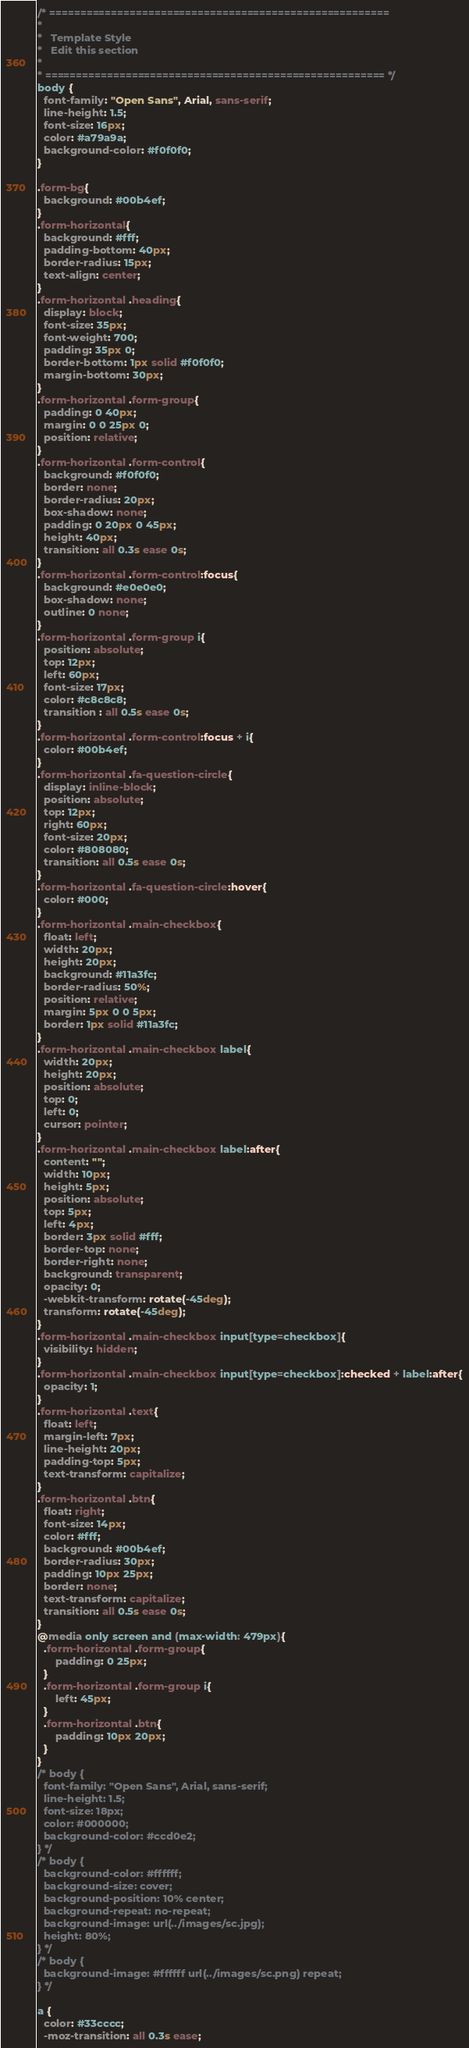<code> <loc_0><loc_0><loc_500><loc_500><_CSS_>/* =======================================================
*
* 	Template Style 
*	Edit this section
*
* ======================================================= */
body {
  font-family: "Open Sans", Arial, sans-serif;
  line-height: 1.5;
  font-size: 16px;
  color: #a79a9a;
  background-color: #f0f0f0;
}

.form-bg{
  background: #00b4ef;
}
.form-horizontal{
  background: #fff;
  padding-bottom: 40px;
  border-radius: 15px;
  text-align: center;
}
.form-horizontal .heading{
  display: block;
  font-size: 35px;
  font-weight: 700;
  padding: 35px 0;
  border-bottom: 1px solid #f0f0f0;
  margin-bottom: 30px;
}
.form-horizontal .form-group{
  padding: 0 40px;
  margin: 0 0 25px 0;
  position: relative;
}
.form-horizontal .form-control{
  background: #f0f0f0;
  border: none;
  border-radius: 20px;
  box-shadow: none;
  padding: 0 20px 0 45px;
  height: 40px;
  transition: all 0.3s ease 0s;
}
.form-horizontal .form-control:focus{
  background: #e0e0e0;
  box-shadow: none;
  outline: 0 none;
}
.form-horizontal .form-group i{
  position: absolute;
  top: 12px;
  left: 60px;
  font-size: 17px;
  color: #c8c8c8;
  transition : all 0.5s ease 0s;
}
.form-horizontal .form-control:focus + i{
  color: #00b4ef;
}
.form-horizontal .fa-question-circle{
  display: inline-block;
  position: absolute;
  top: 12px;
  right: 60px;
  font-size: 20px;
  color: #808080;
  transition: all 0.5s ease 0s;
}
.form-horizontal .fa-question-circle:hover{
  color: #000;
}
.form-horizontal .main-checkbox{
  float: left;
  width: 20px;
  height: 20px;
  background: #11a3fc;
  border-radius: 50%;
  position: relative;
  margin: 5px 0 0 5px;
  border: 1px solid #11a3fc;
}
.form-horizontal .main-checkbox label{
  width: 20px;
  height: 20px;
  position: absolute;
  top: 0;
  left: 0;
  cursor: pointer;
}
.form-horizontal .main-checkbox label:after{
  content: "";
  width: 10px;
  height: 5px;
  position: absolute;
  top: 5px;
  left: 4px;
  border: 3px solid #fff;
  border-top: none;
  border-right: none;
  background: transparent;
  opacity: 0;
  -webkit-transform: rotate(-45deg);
  transform: rotate(-45deg);
}
.form-horizontal .main-checkbox input[type=checkbox]{
  visibility: hidden;
}
.form-horizontal .main-checkbox input[type=checkbox]:checked + label:after{
  opacity: 1;
}
.form-horizontal .text{
  float: left;
  margin-left: 7px;
  line-height: 20px;
  padding-top: 5px;
  text-transform: capitalize;
}
.form-horizontal .btn{
  float: right;
  font-size: 14px;
  color: #fff;
  background: #00b4ef;
  border-radius: 30px;
  padding: 10px 25px;
  border: none;
  text-transform: capitalize;
  transition: all 0.5s ease 0s;
}
@media only screen and (max-width: 479px){
  .form-horizontal .form-group{
      padding: 0 25px;
  }
  .form-horizontal .form-group i{
      left: 45px;
  }
  .form-horizontal .btn{
      padding: 10px 20px;
  }
}
/* body {
  font-family: "Open Sans", Arial, sans-serif;
  line-height: 1.5;
  font-size: 18px;
  color: #000000;
  background-color: #ccd0e2;
} */
/* body {
  background-color: #ffffff;
  background-size: cover;
  background-position: 10% center;
  background-repeat: no-repeat;
  background-image: url(../images/sc.jpg);
  height: 80%;
} */
/* body {
  background-image: #ffffff url(../images/sc.png) repeat;
} */

a {
  color: #33cccc;
  -moz-transition: all 0.3s ease;</code> 